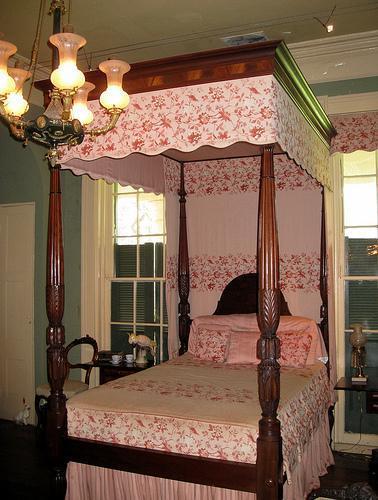How many beds are in the picture?
Give a very brief answer. 1. 